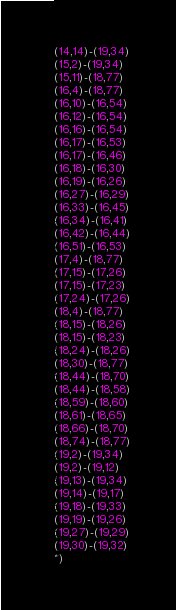Convert code to text. <code><loc_0><loc_0><loc_500><loc_500><_OCaml_>(14,14)-(19,34)
(15,2)-(19,34)
(15,11)-(18,77)
(16,4)-(18,77)
(16,10)-(16,54)
(16,12)-(16,54)
(16,16)-(16,54)
(16,17)-(16,53)
(16,17)-(16,46)
(16,18)-(16,30)
(16,19)-(16,26)
(16,27)-(16,29)
(16,33)-(16,45)
(16,34)-(16,41)
(16,42)-(16,44)
(16,51)-(16,53)
(17,4)-(18,77)
(17,15)-(17,26)
(17,15)-(17,23)
(17,24)-(17,26)
(18,4)-(18,77)
(18,15)-(18,26)
(18,15)-(18,23)
(18,24)-(18,26)
(18,30)-(18,77)
(18,44)-(18,70)
(18,44)-(18,58)
(18,59)-(18,60)
(18,61)-(18,65)
(18,66)-(18,70)
(18,74)-(18,77)
(19,2)-(19,34)
(19,2)-(19,12)
(19,13)-(19,34)
(19,14)-(19,17)
(19,18)-(19,33)
(19,19)-(19,26)
(19,27)-(19,29)
(19,30)-(19,32)
*)
</code> 